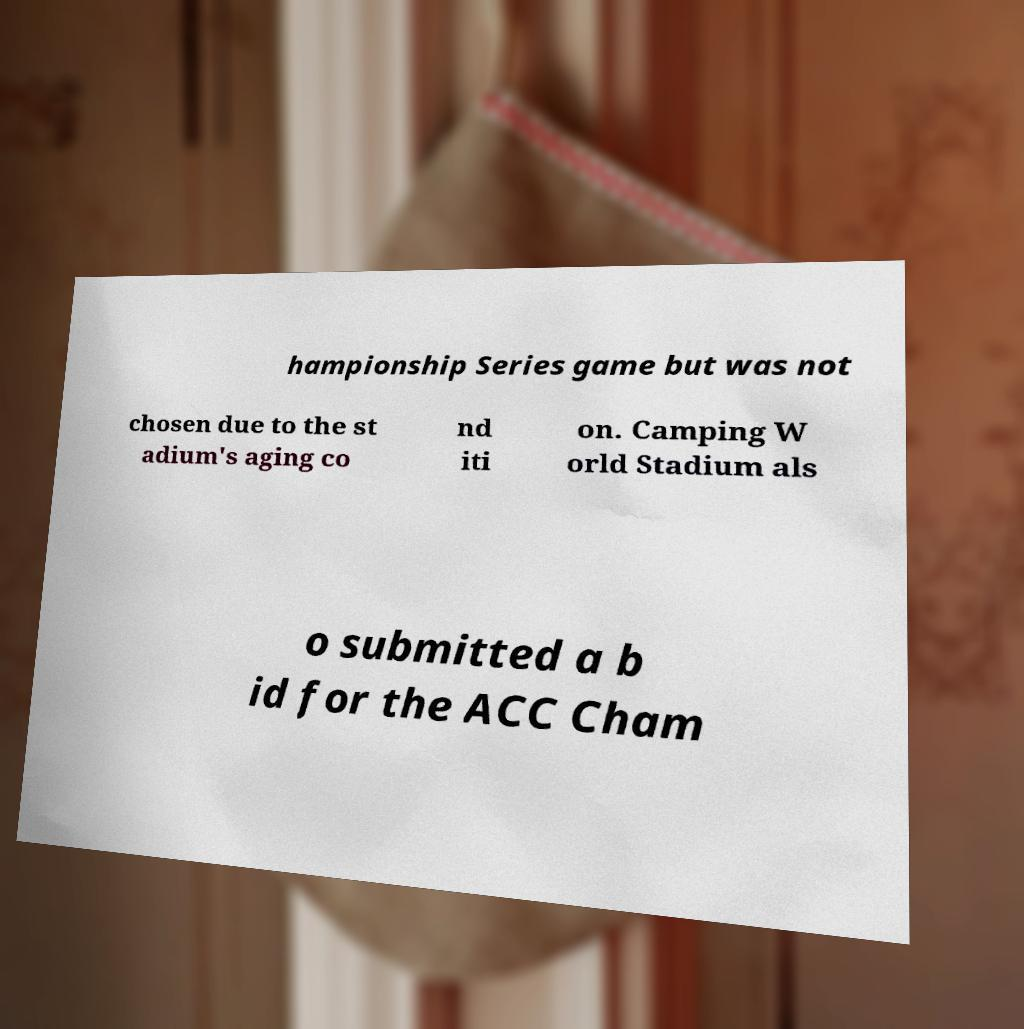What messages or text are displayed in this image? I need them in a readable, typed format. hampionship Series game but was not chosen due to the st adium's aging co nd iti on. Camping W orld Stadium als o submitted a b id for the ACC Cham 